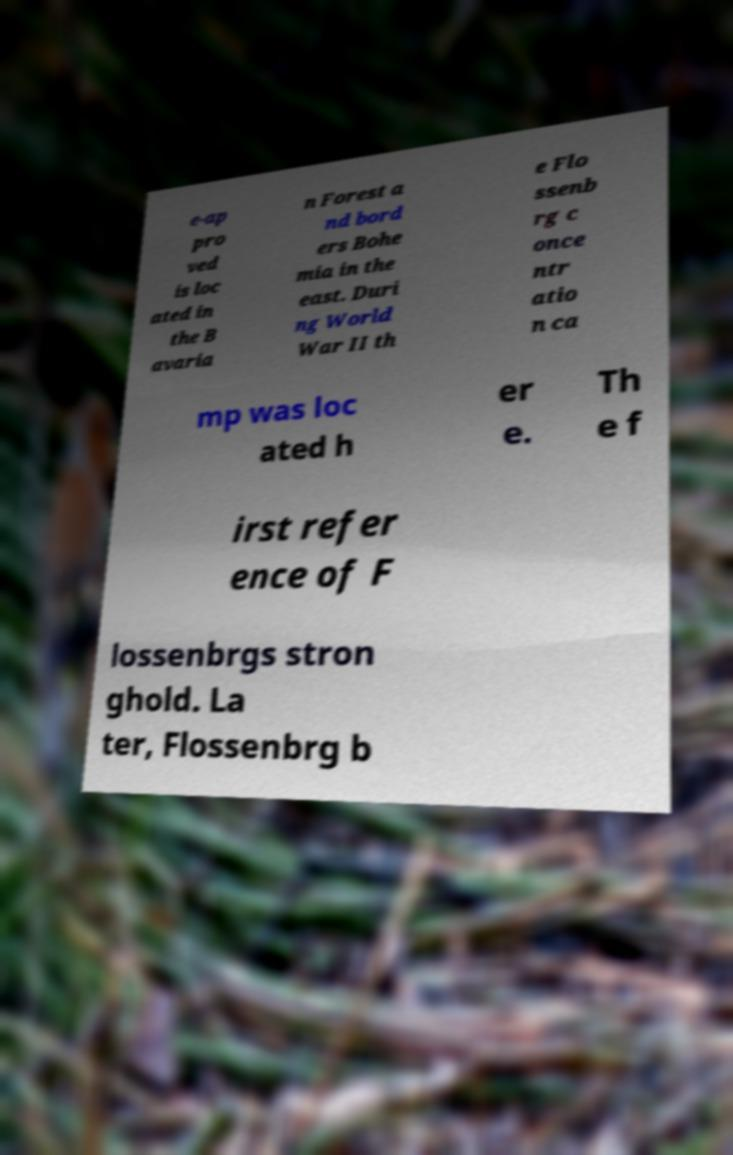There's text embedded in this image that I need extracted. Can you transcribe it verbatim? e-ap pro ved is loc ated in the B avaria n Forest a nd bord ers Bohe mia in the east. Duri ng World War II th e Flo ssenb rg c once ntr atio n ca mp was loc ated h er e. Th e f irst refer ence of F lossenbrgs stron ghold. La ter, Flossenbrg b 